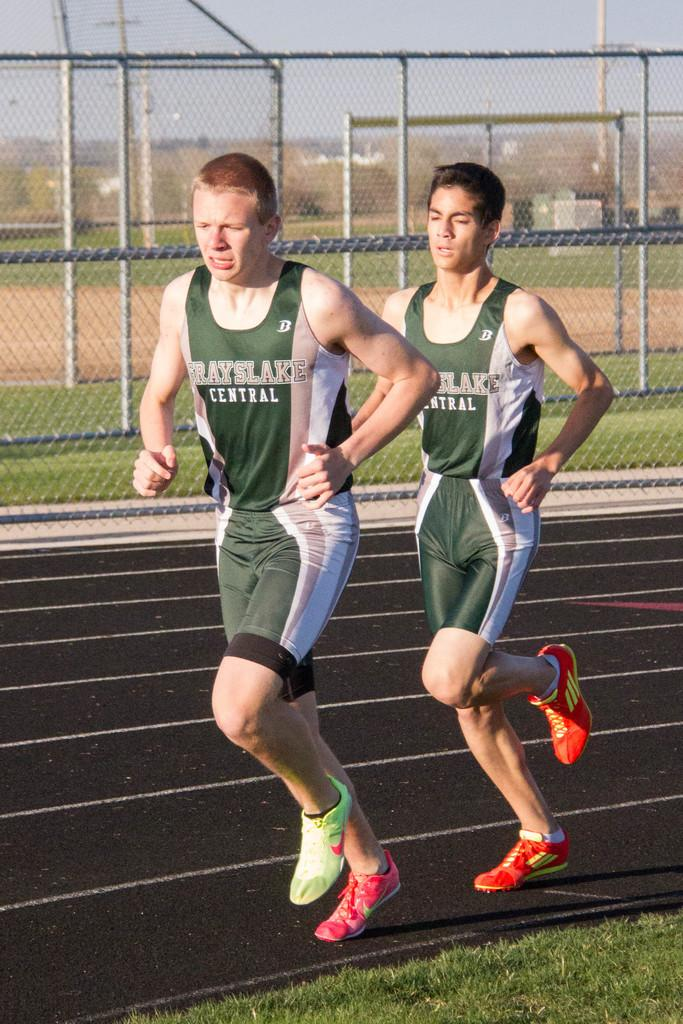<image>
Write a terse but informative summary of the picture. a couple runners from Grayslake central running with each other 